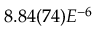<formula> <loc_0><loc_0><loc_500><loc_500>8 . 8 4 ( 7 4 ) E ^ { - 6 }</formula> 